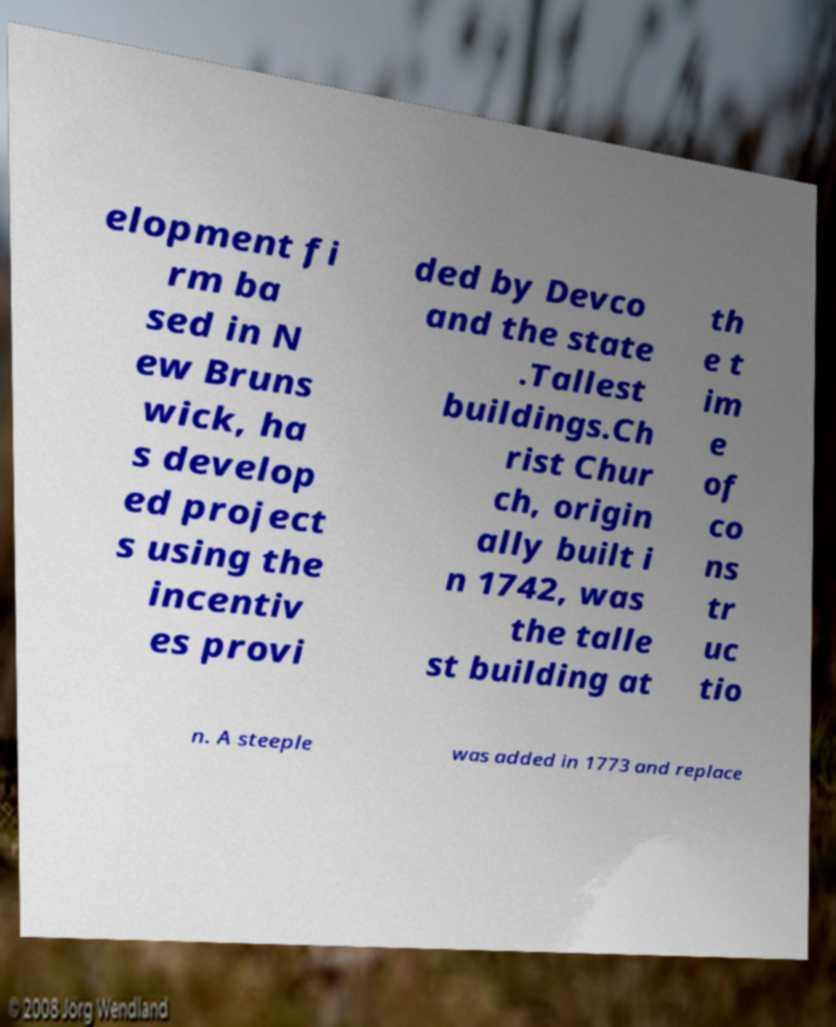For documentation purposes, I need the text within this image transcribed. Could you provide that? elopment fi rm ba sed in N ew Bruns wick, ha s develop ed project s using the incentiv es provi ded by Devco and the state .Tallest buildings.Ch rist Chur ch, origin ally built i n 1742, was the talle st building at th e t im e of co ns tr uc tio n. A steeple was added in 1773 and replace 